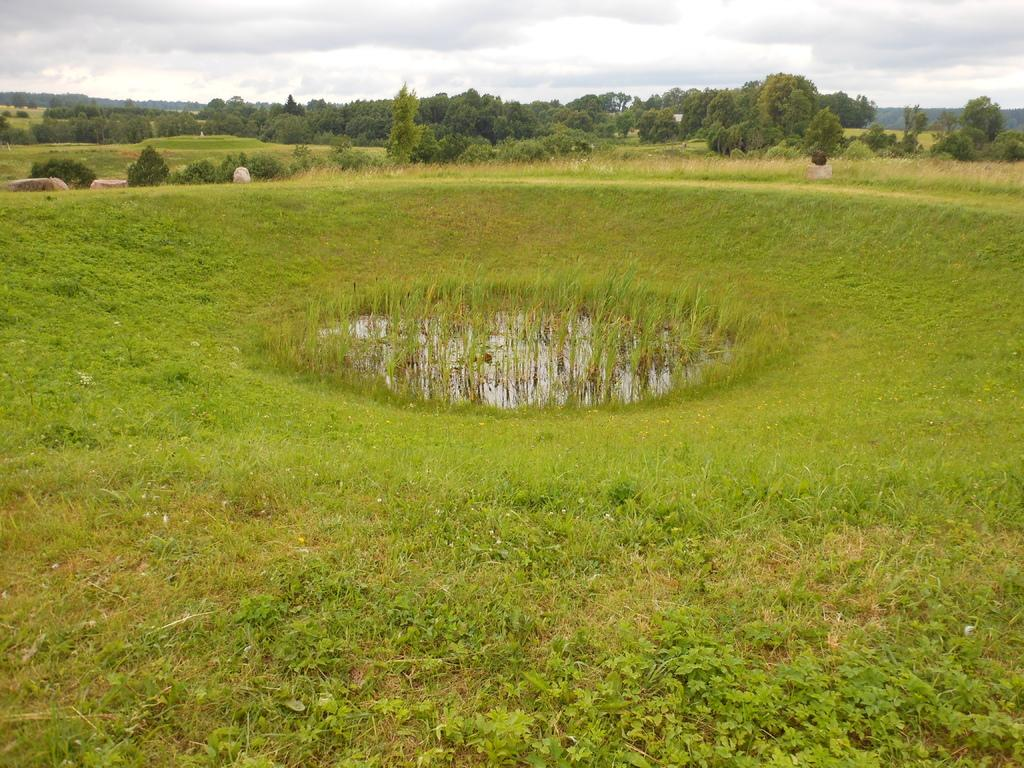What type of vegetation is present on the ground in the image? There are plants and grass on the ground in the image. What can be seen in the center of the image? There is water with plants in the center of the image. What is visible in the background of the image? There are trees and the sky visible in the background of the image. Can you tell me what time the girl is watching the wax melt in the image? There is no girl, watch, or wax present in the image. 